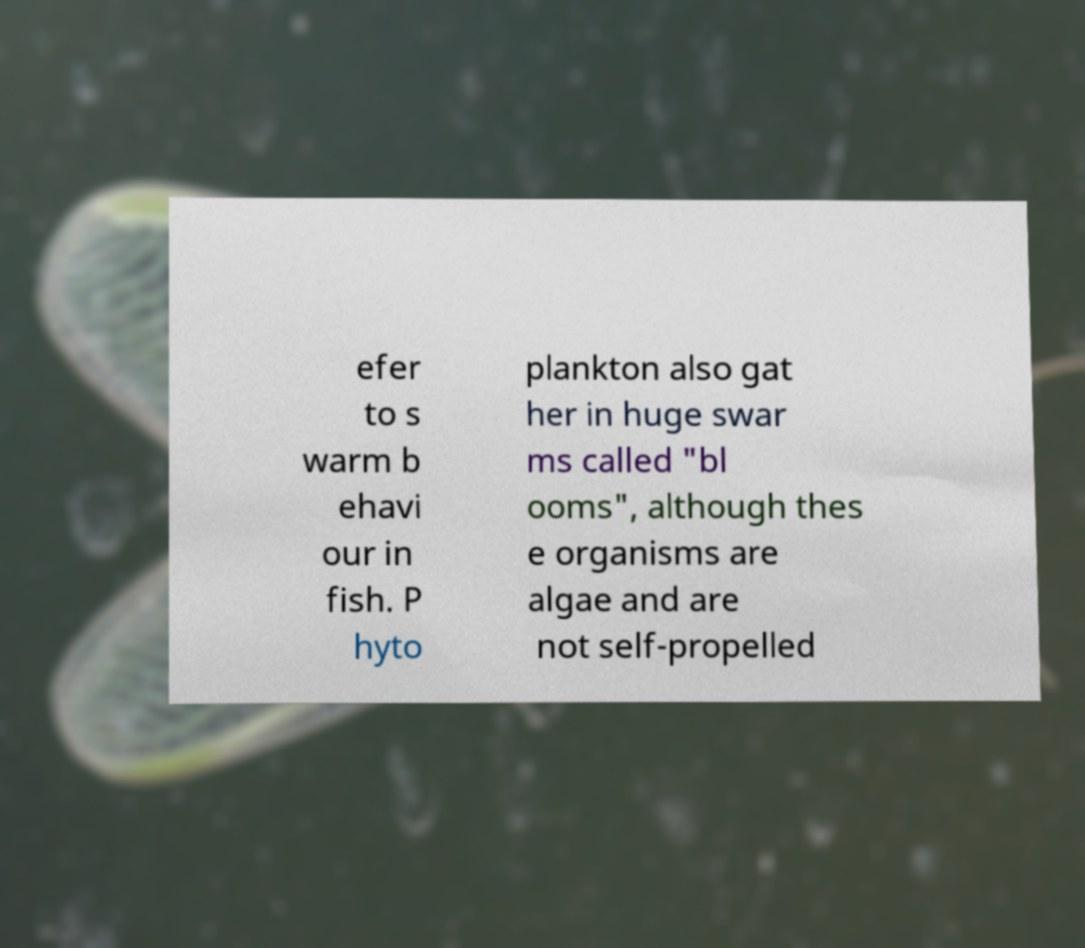Could you extract and type out the text from this image? efer to s warm b ehavi our in fish. P hyto plankton also gat her in huge swar ms called "bl ooms", although thes e organisms are algae and are not self-propelled 